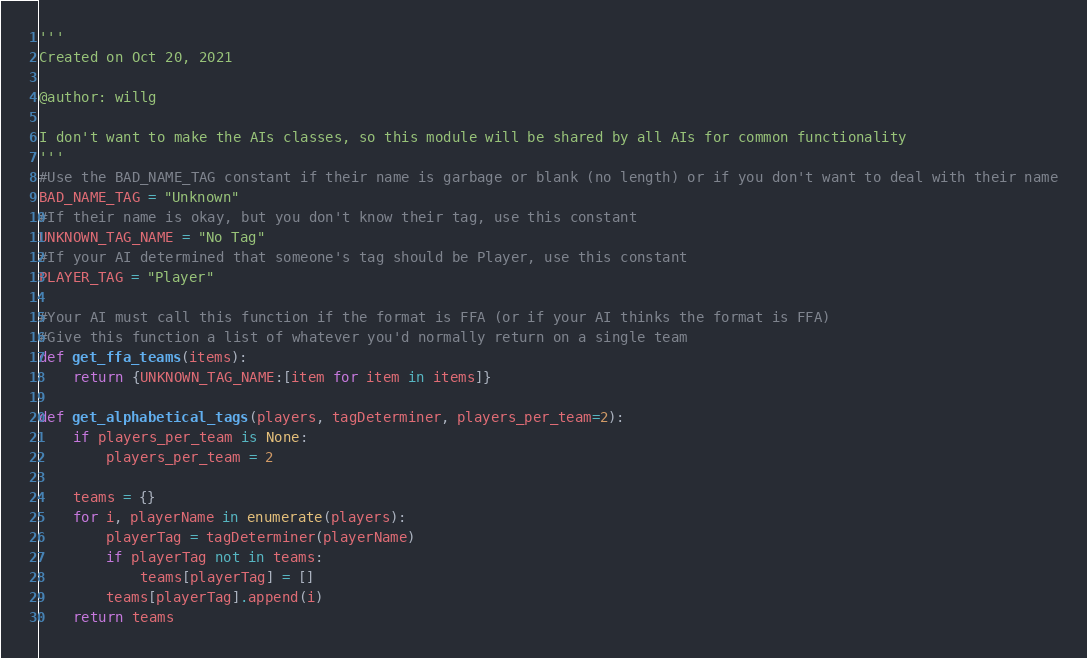Convert code to text. <code><loc_0><loc_0><loc_500><loc_500><_Python_>'''
Created on Oct 20, 2021

@author: willg

I don't want to make the AIs classes, so this module will be shared by all AIs for common functionality
'''
#Use the BAD_NAME_TAG constant if their name is garbage or blank (no length) or if you don't want to deal with their name
BAD_NAME_TAG = "Unknown"
#If their name is okay, but you don't know their tag, use this constant
UNKNOWN_TAG_NAME = "No Tag"
#If your AI determined that someone's tag should be Player, use this constant
PLAYER_TAG = "Player"

#Your AI must call this function if the format is FFA (or if your AI thinks the format is FFA)
#Give this function a list of whatever you'd normally return on a single team
def get_ffa_teams(items):
    return {UNKNOWN_TAG_NAME:[item for item in items]}

def get_alphabetical_tags(players, tagDeterminer, players_per_team=2):
    if players_per_team is None:
        players_per_team = 2
    
    teams = {}
    for i, playerName in enumerate(players):
        playerTag = tagDeterminer(playerName)
        if playerTag not in teams:
            teams[playerTag] = []
        teams[playerTag].append(i)
    return teams</code> 